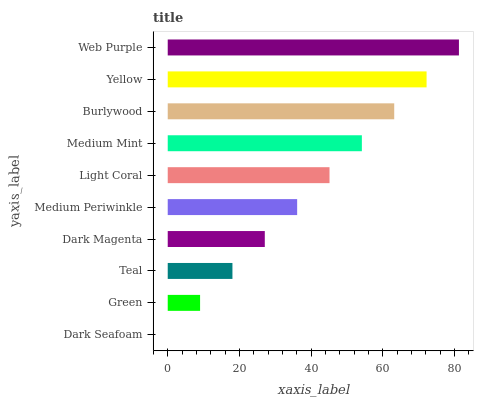Is Dark Seafoam the minimum?
Answer yes or no. Yes. Is Web Purple the maximum?
Answer yes or no. Yes. Is Green the minimum?
Answer yes or no. No. Is Green the maximum?
Answer yes or no. No. Is Green greater than Dark Seafoam?
Answer yes or no. Yes. Is Dark Seafoam less than Green?
Answer yes or no. Yes. Is Dark Seafoam greater than Green?
Answer yes or no. No. Is Green less than Dark Seafoam?
Answer yes or no. No. Is Light Coral the high median?
Answer yes or no. Yes. Is Medium Periwinkle the low median?
Answer yes or no. Yes. Is Web Purple the high median?
Answer yes or no. No. Is Teal the low median?
Answer yes or no. No. 